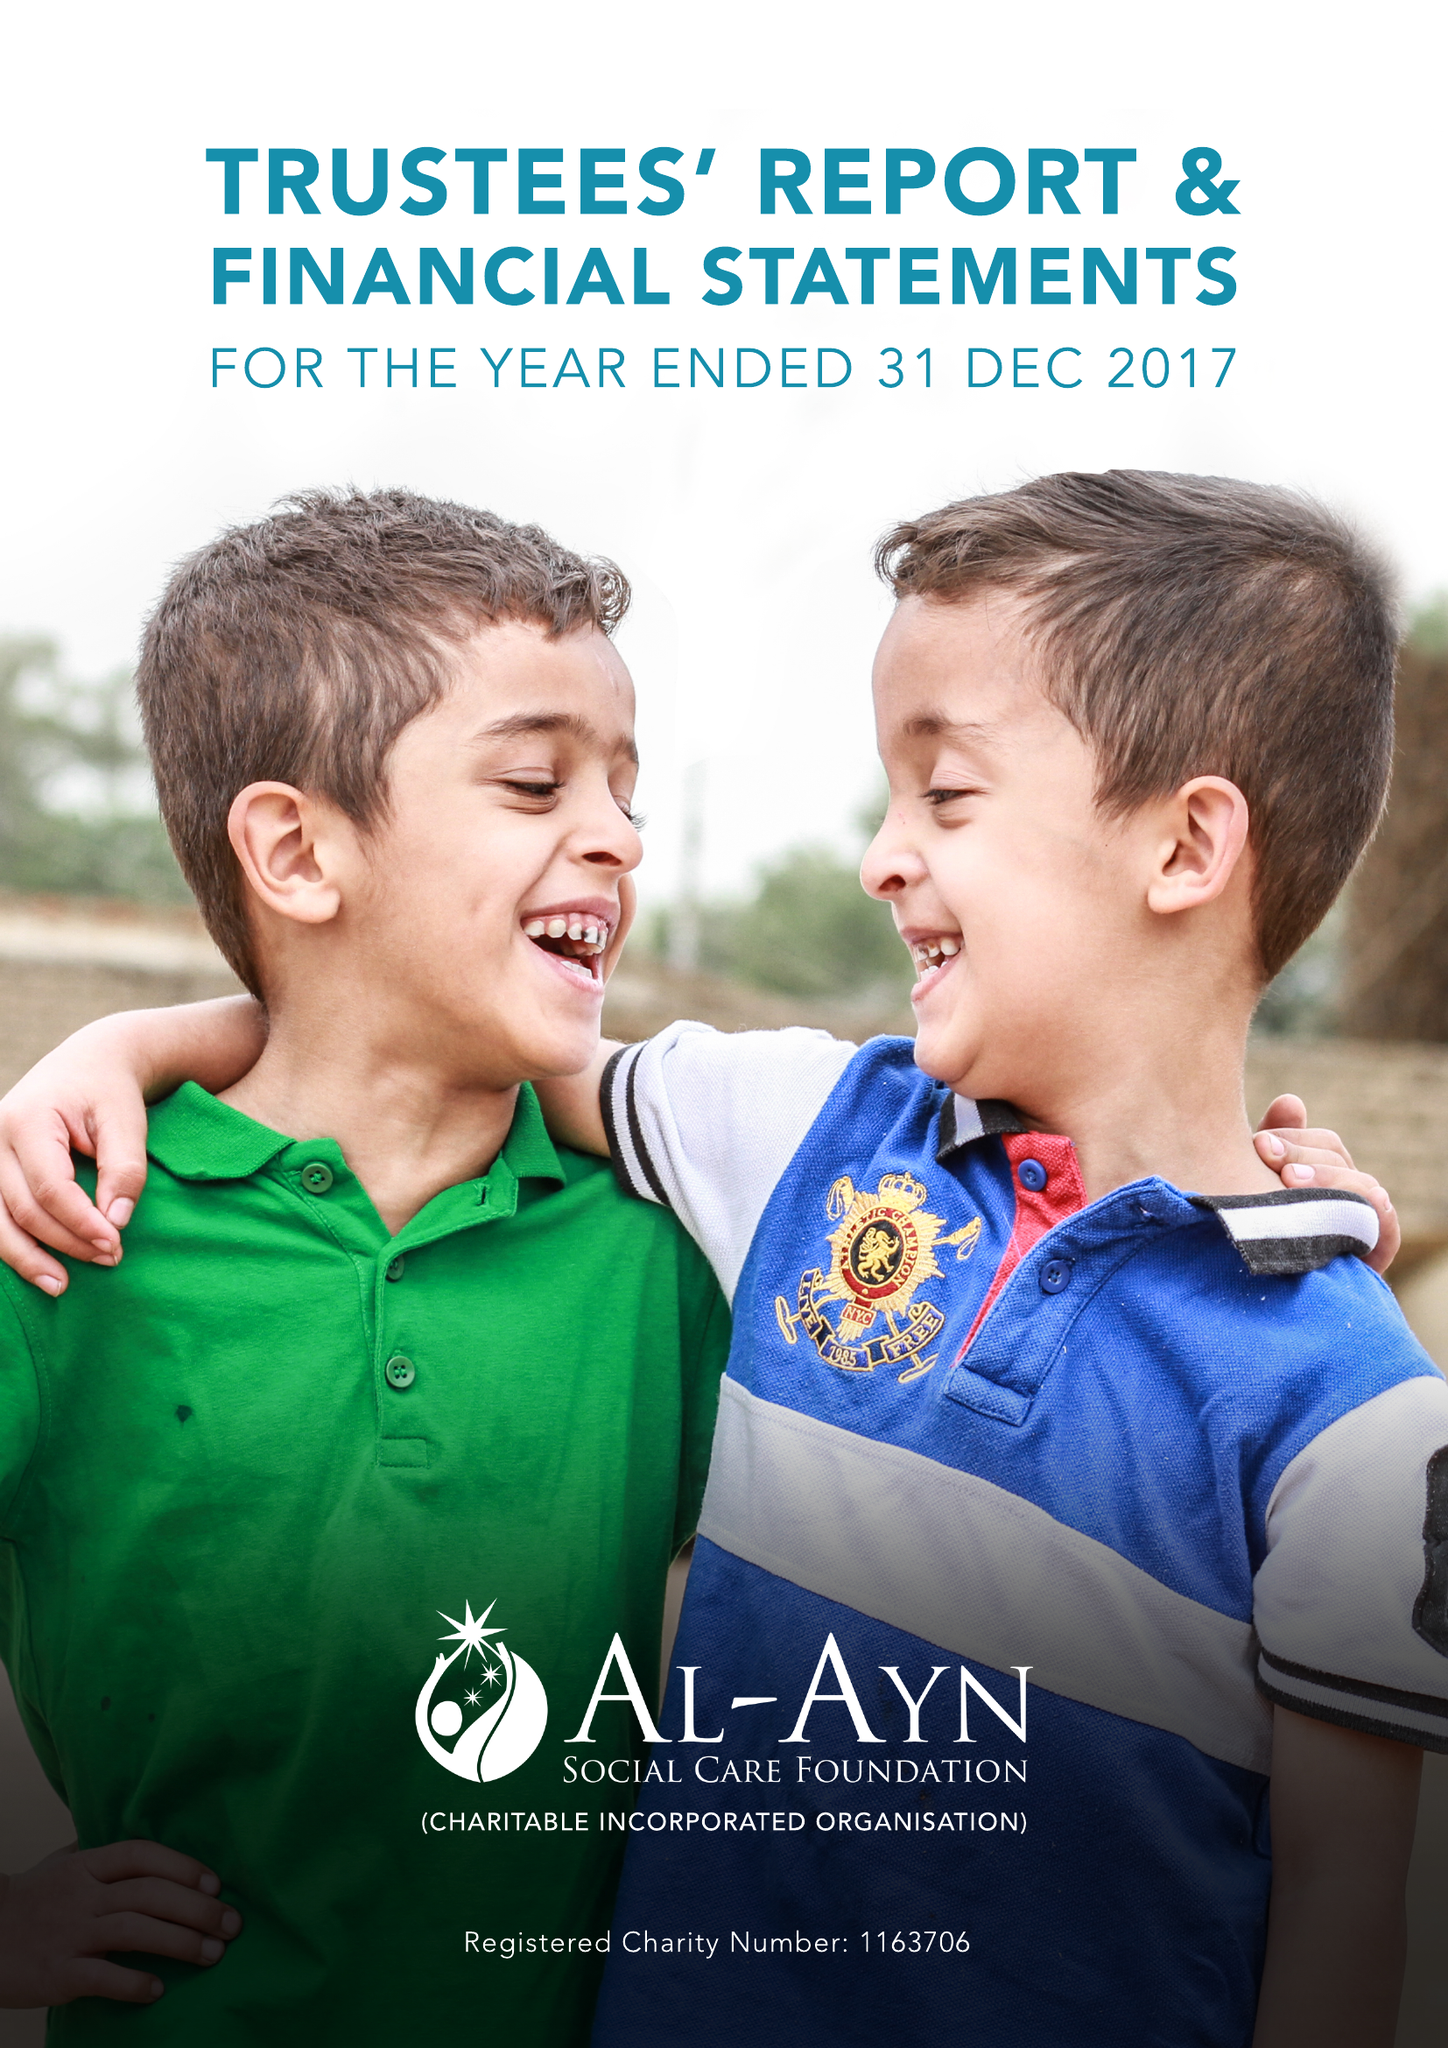What is the value for the income_annually_in_british_pounds?
Answer the question using a single word or phrase. 14116938.00 